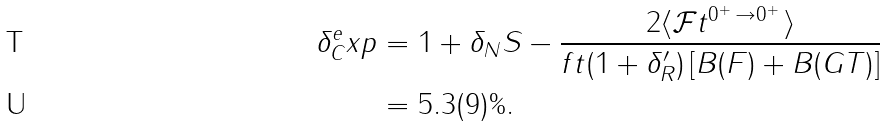Convert formula to latex. <formula><loc_0><loc_0><loc_500><loc_500>\delta _ { C } ^ { e } x p & = 1 + \delta _ { N } S - \frac { 2 \langle \mathcal { F } t ^ { 0 ^ { + } \, \rightarrow 0 ^ { + } \, } \rangle } { f t ( 1 + \delta _ { R } ^ { \prime } ) \left [ B ( F ) + B ( G T ) \right ] } \\ & = 5 . 3 ( 9 ) \% .</formula> 